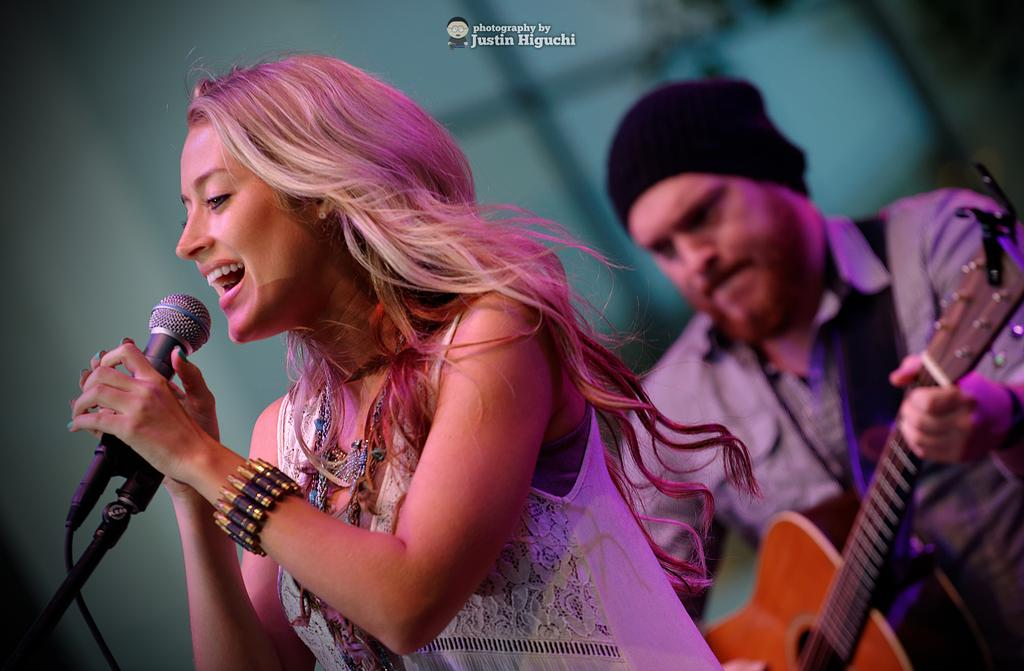What is the man in the image doing? The man is playing a guitar. What is the man wearing on his head? The man is wearing a black cap. What is the woman in the image doing? The woman is singing. What object is the woman holding in her hands? The woman is holding a microphone in her hands. What type of root can be seen growing in the image? There is no root visible in the image. What is the reason for the protest in the image? There is no protest depicted in the image. 